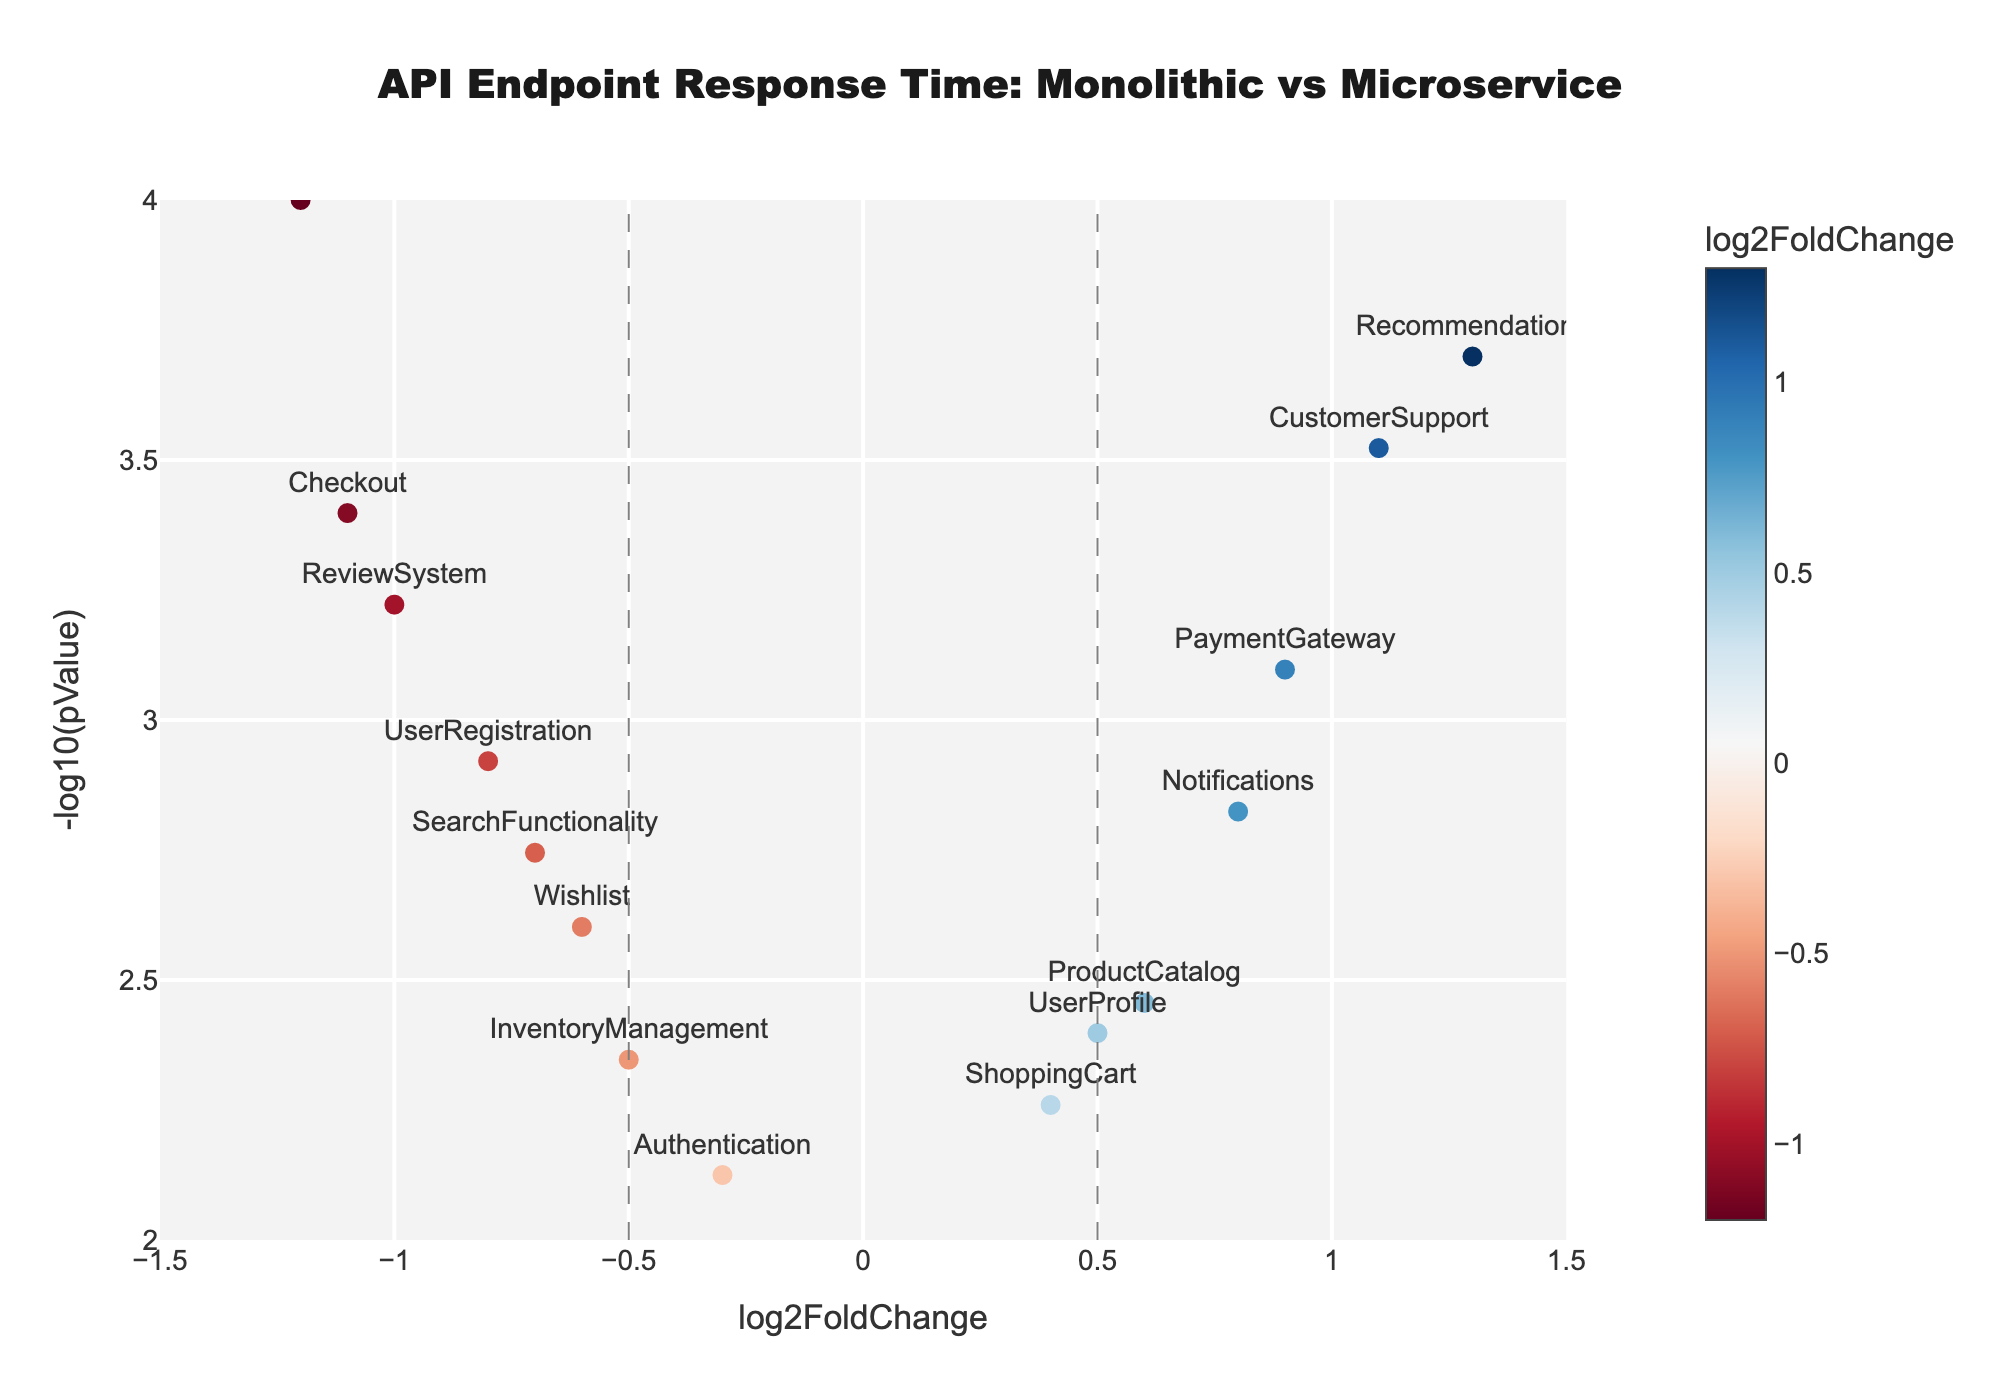What is the title of the figure? The title is usually displayed at the top center of the figure. By reading the text in this specific location, you can determine the title.
Answer: API Endpoint Response Time: Monolithic vs Microservice What does the x-axis represent? The axis titles are usually shown next to the axis. The x-axis title in this figure indicates what is represented along the horizontal axis.
Answer: log2FoldChange Which API Endpoint has the highest -log10(pValue)? To determine this, look for the data point with the highest value on the y-axis. The endpoint label next to this point will be the one with the highest -log10(pValue).
Answer: OrderProcessing How many API endpoints have a log2FoldChange greater than 0.5? Focus on the points to the right of the vertical line at x=0.5, then count the total number of these points.
Answer: 4 Are there more endpoints with a positive or negative log2FoldChange? Count the data points to the right (positive) and left (negative) of the vertical line at x=0, then compare these totals.
Answer: Negative Which endpoint shows the greatest improvement in response time in microservices? Find the endpoint with the highest positive log2FoldChange value on the x-axis. This endpoint has the greatest improvement in response time.
Answer: Recommendations What is the pValue for the ReviewSystem endpoint? Locate the ReviewSystem point on the plot, refer to the hover text or label, and read the corresponding pValue.
Answer: 0.0006 Which two endpoints have the most significant differences in response time? Significant differences are indicated by points farthest from the vertical line at x=0 (both in positive and negative directions). Identify the two endpoints with the greatest absolute log2FoldChange values.
Answer: OrderProcessing and Recommendations What log2FoldChange value marks a significant change in response time? Look for the vertical line marking significance thresholds in log2FoldChange values. These lines usually indicate thresholds like -0.5 and 0.5.
Answer: ±0.5 Considering the -log10(pValue) significance cutoff (horizontal line), which endpoints are not statistically significant? Identify the horizontal line usually marking a common significance level like -log10(0.05), then find endpoints below this line.
Answer: Authentication and ShoppingCart 